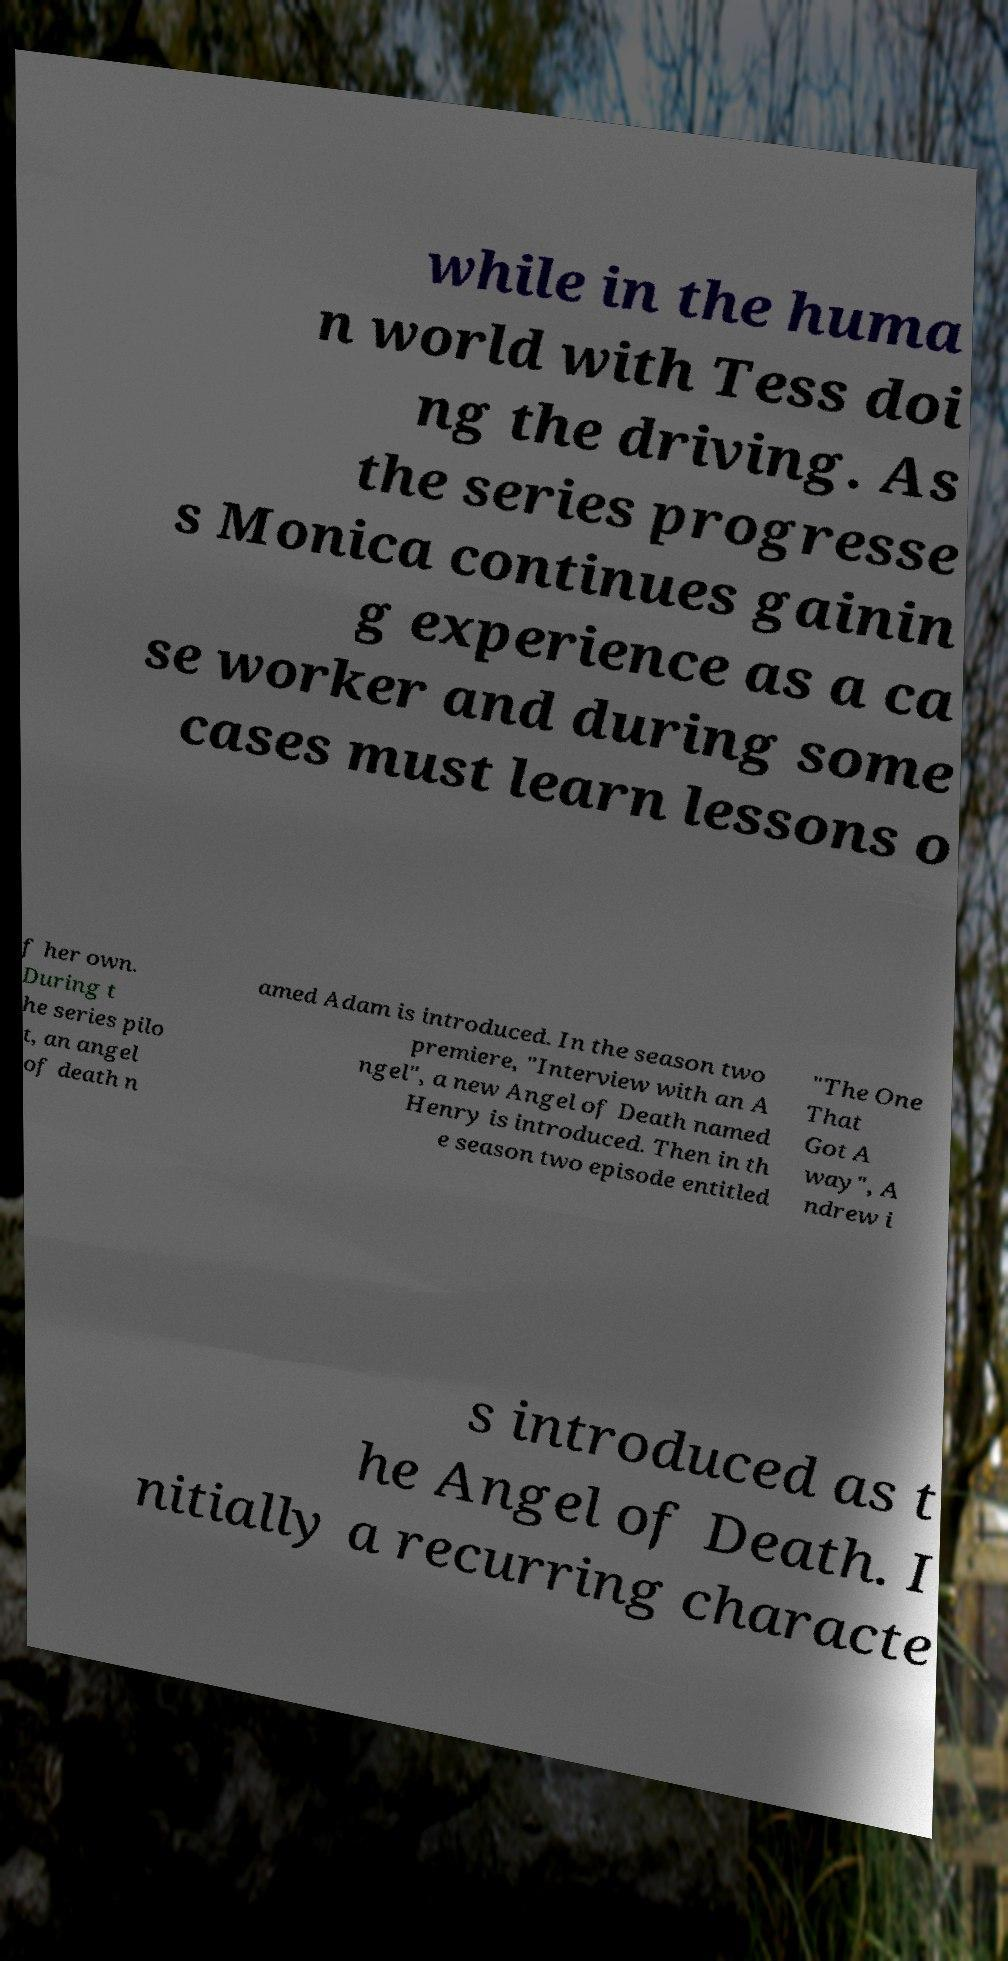Please read and relay the text visible in this image. What does it say? while in the huma n world with Tess doi ng the driving. As the series progresse s Monica continues gainin g experience as a ca se worker and during some cases must learn lessons o f her own. During t he series pilo t, an angel of death n amed Adam is introduced. In the season two premiere, "Interview with an A ngel", a new Angel of Death named Henry is introduced. Then in th e season two episode entitled "The One That Got A way", A ndrew i s introduced as t he Angel of Death. I nitially a recurring characte 